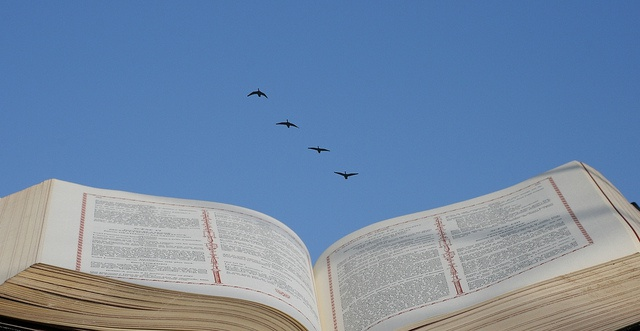Describe the objects in this image and their specific colors. I can see book in gray, darkgray, and lightgray tones, bird in gray, black, and blue tones, bird in gray, black, blue, and navy tones, bird in gray, black, and navy tones, and bird in gray, black, and blue tones in this image. 